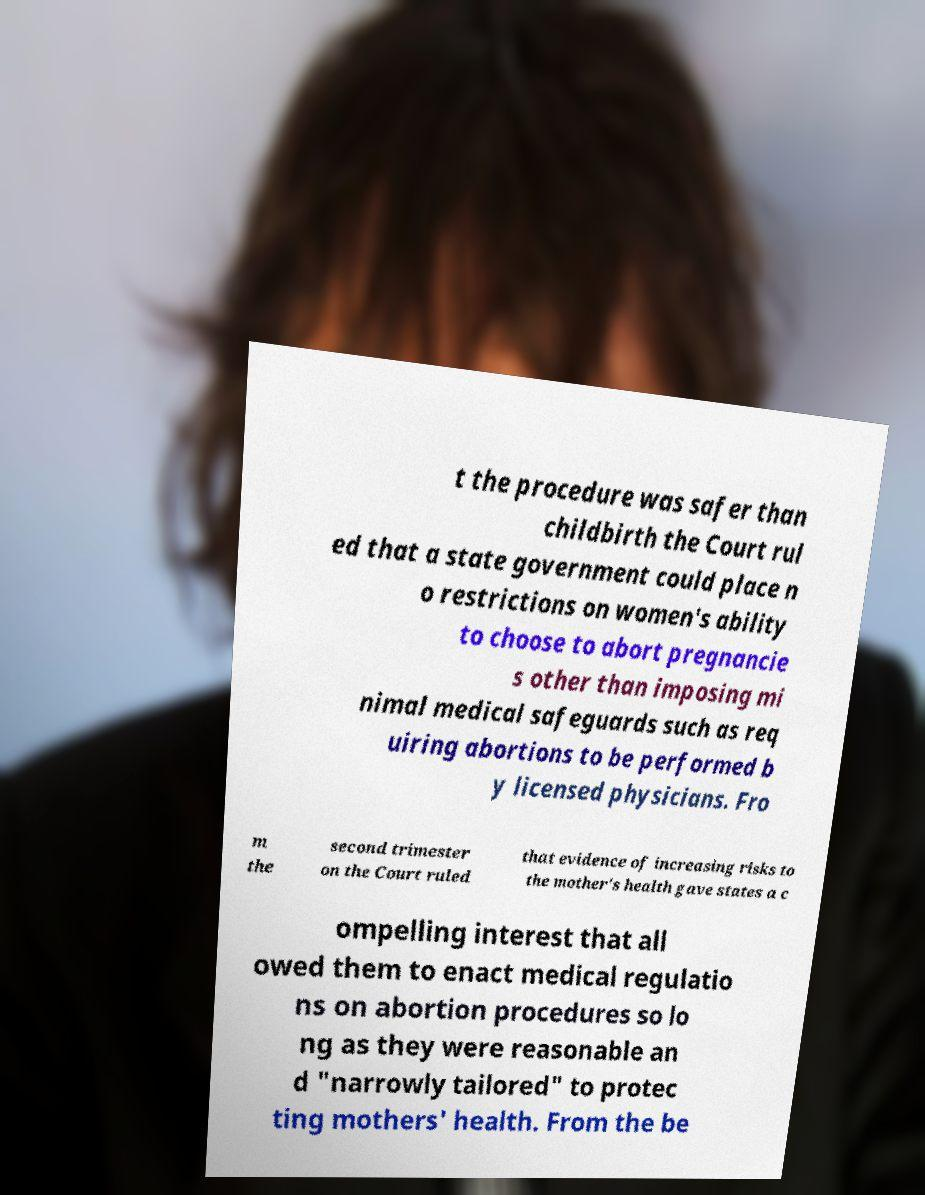Could you extract and type out the text from this image? t the procedure was safer than childbirth the Court rul ed that a state government could place n o restrictions on women's ability to choose to abort pregnancie s other than imposing mi nimal medical safeguards such as req uiring abortions to be performed b y licensed physicians. Fro m the second trimester on the Court ruled that evidence of increasing risks to the mother's health gave states a c ompelling interest that all owed them to enact medical regulatio ns on abortion procedures so lo ng as they were reasonable an d "narrowly tailored" to protec ting mothers' health. From the be 